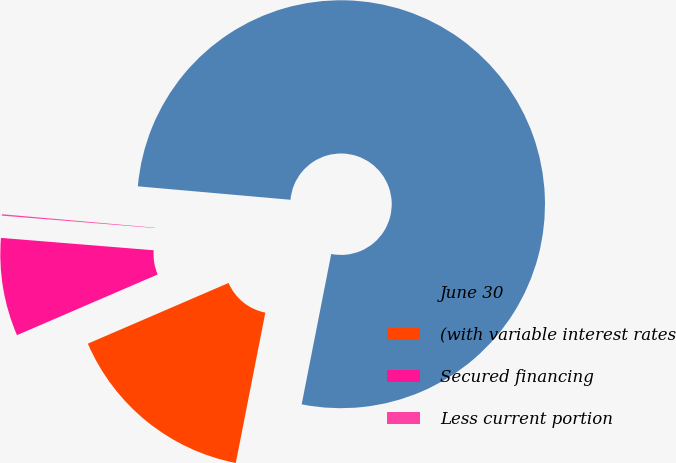Convert chart. <chart><loc_0><loc_0><loc_500><loc_500><pie_chart><fcel>June 30<fcel>(with variable interest rates<fcel>Secured financing<fcel>Less current portion<nl><fcel>76.7%<fcel>15.43%<fcel>7.77%<fcel>0.11%<nl></chart> 